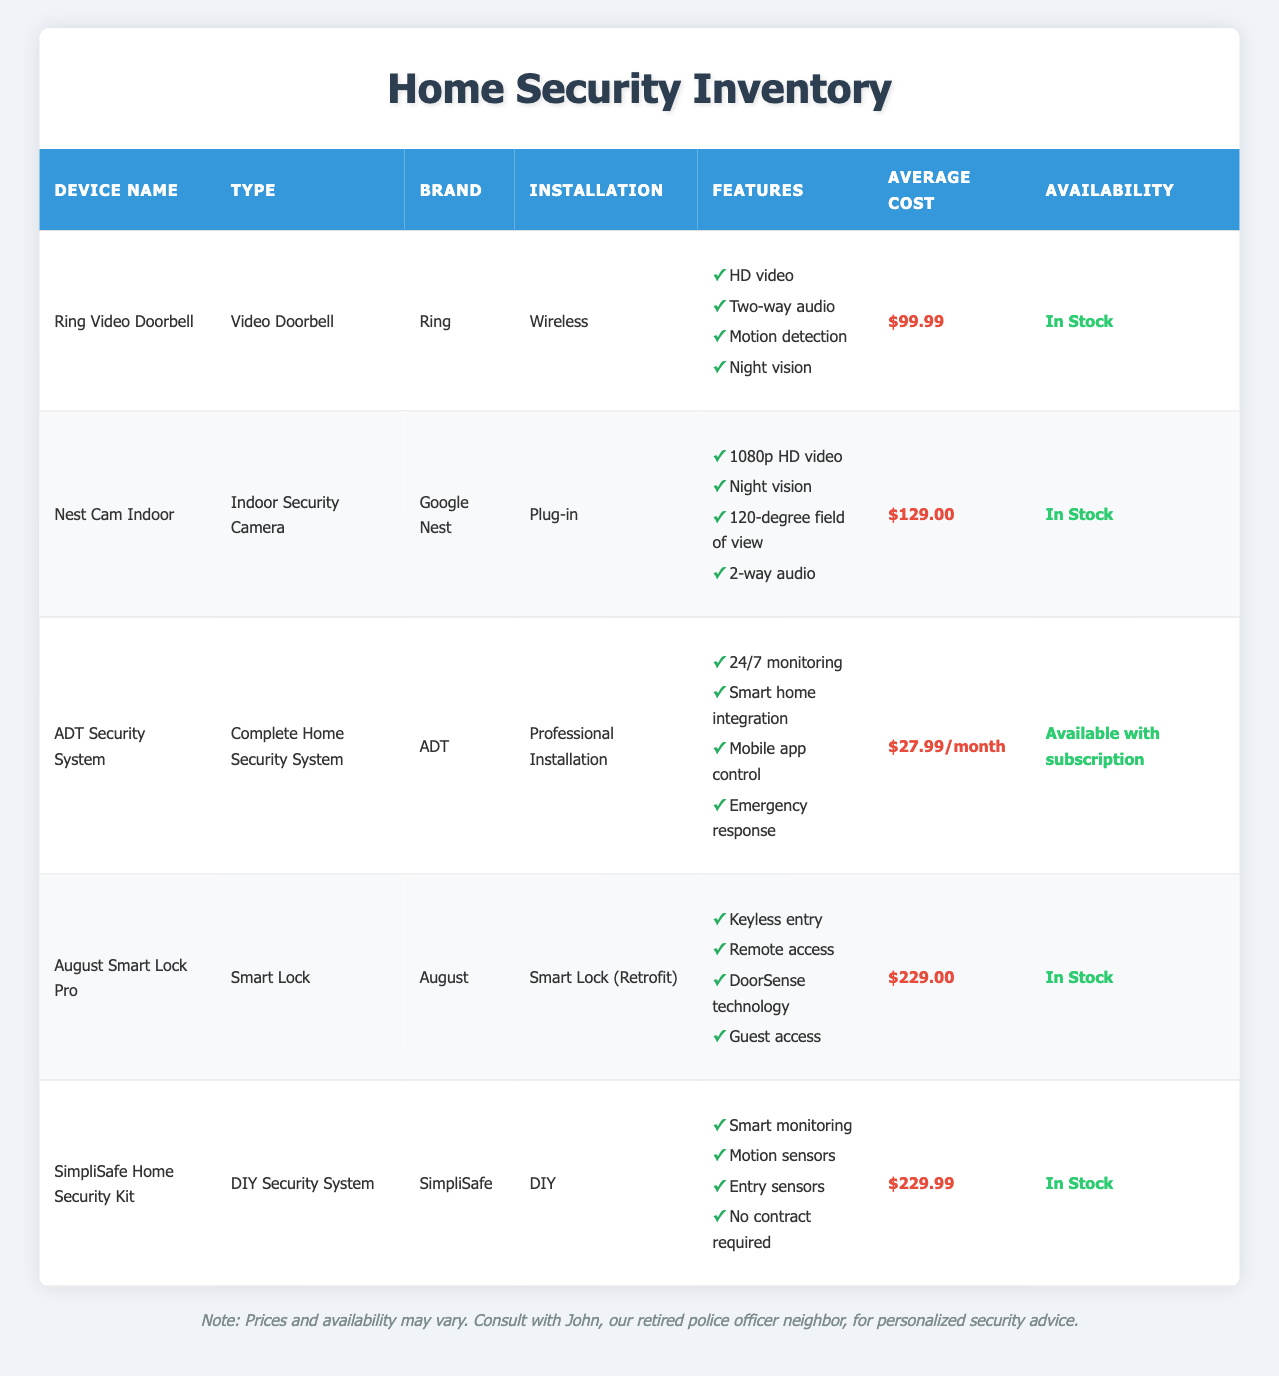What is the average cost of the devices listed? To find the average cost, first add all the average costs: 99.99 + 129.00 + 27.99 + 229.00 + 229.99 = 715.97. Then, divide the total by the number of devices (5), which gives us 715.97 / 5 = 143.194. Rounding this to two decimal places gives us an average cost of 143.19.
Answer: 143.19 Which device has the highest average cost? By examining the average costs of each device, August Smart Lock Pro has an average cost of 229.00, which is higher than the others (Ring Video Doorbell - 99.99, Nest Cam Indoor - 129.00, ADT Security System - 27.99/month, SimpliSafe Home Security Kit - 229.99). Therefore, both August Smart Lock Pro and SimpliSafe Home Security Kit have the same highest cost, which can be noted.
Answer: August Smart Lock Pro and SimpliSafe Home Security Kit Is the ADT Security System available without a subscription? Looking at the availability of ADT Security System, it states "Available with subscription," indicating that it is not available without a subscription.
Answer: No How many devices offer two-way audio as a feature? Checking the features for each device: Ring Video Doorbell and Nest Cam Indoor both list "Two-way audio" as a feature. Thus, there are 2 devices that offer this feature.
Answer: 2 Which device offers 24/7 monitoring as a feature? Only the ADT Security System lists "24/7 monitoring" as a feature, indicating that this is the sole device with that capability.
Answer: ADT Security System What type of installation does the August Smart Lock Pro require? The table indicates that the installation type for August Smart Lock Pro is "Smart Lock (Retrofit)," which specifies how that device is set up in a home.
Answer: Smart Lock (Retrofit) Is the SimpliSafe Home Security Kit available for professional installation? The inventory table shows that SimpliSafe Home Security Kit has an installation type of "DIY," which means it is not available for professional installation.
Answer: No Which brand offers an indoor security camera? According to the table, the "Nest Cam Indoor" is the device that functions as an indoor security camera, and it is from the brand Google Nest.
Answer: Google Nest 